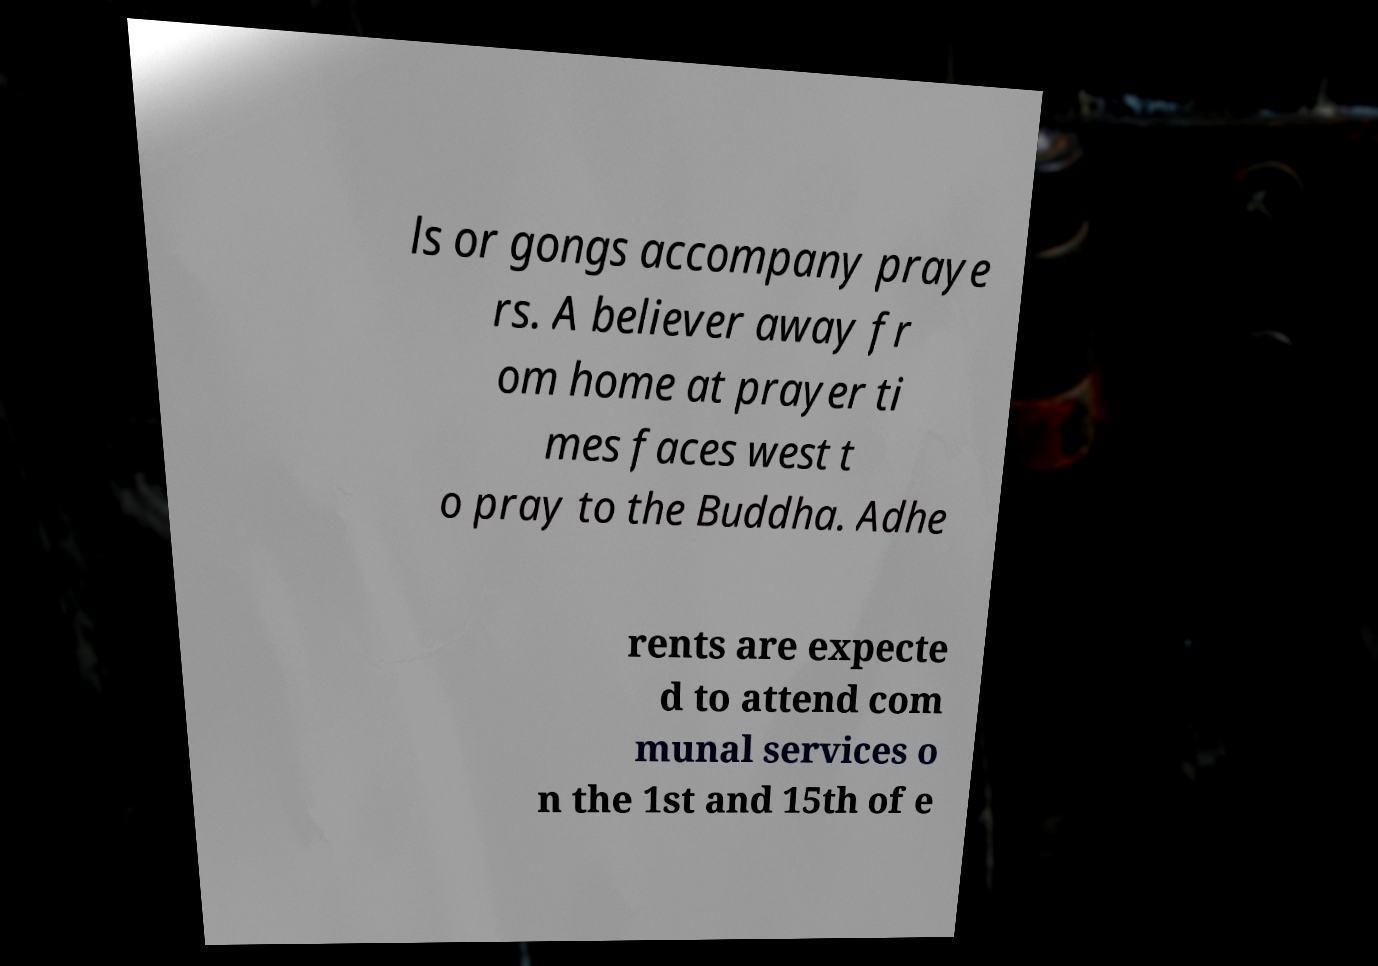Could you assist in decoding the text presented in this image and type it out clearly? ls or gongs accompany praye rs. A believer away fr om home at prayer ti mes faces west t o pray to the Buddha. Adhe rents are expecte d to attend com munal services o n the 1st and 15th of e 